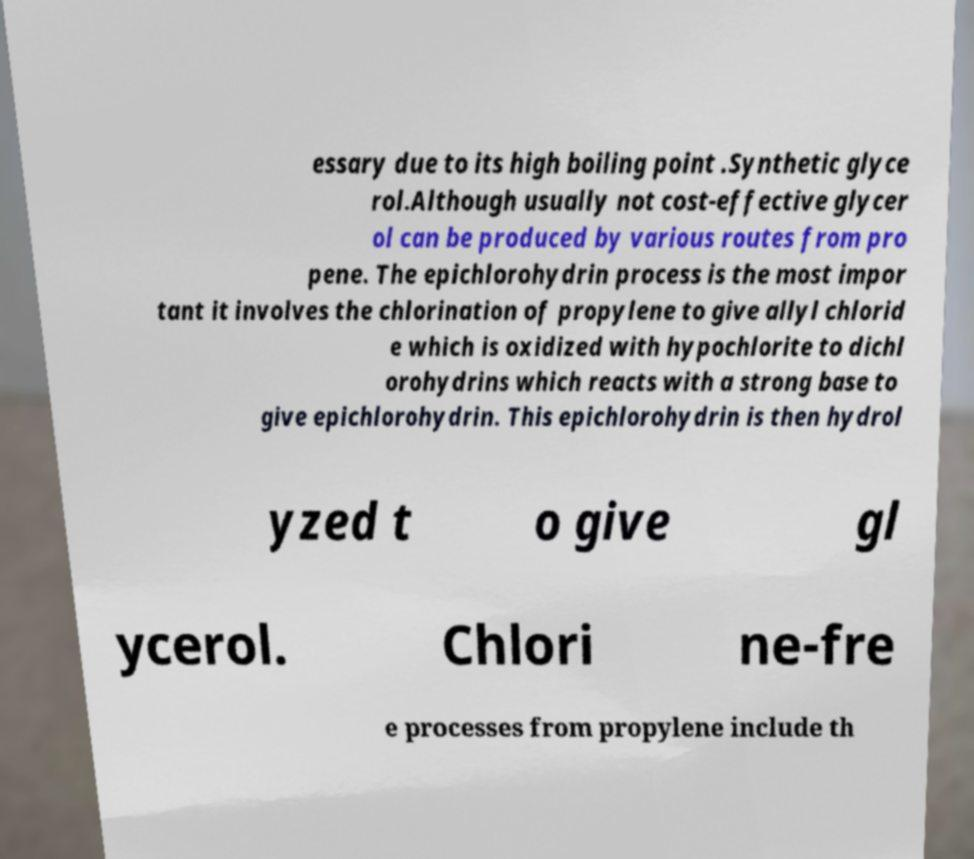There's text embedded in this image that I need extracted. Can you transcribe it verbatim? essary due to its high boiling point .Synthetic glyce rol.Although usually not cost-effective glycer ol can be produced by various routes from pro pene. The epichlorohydrin process is the most impor tant it involves the chlorination of propylene to give allyl chlorid e which is oxidized with hypochlorite to dichl orohydrins which reacts with a strong base to give epichlorohydrin. This epichlorohydrin is then hydrol yzed t o give gl ycerol. Chlori ne-fre e processes from propylene include th 